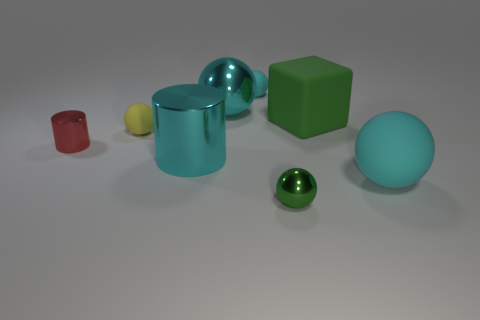Subtract all red cylinders. How many cyan balls are left? 3 Subtract 1 spheres. How many spheres are left? 4 Subtract all yellow spheres. How many spheres are left? 4 Subtract all small cyan matte spheres. How many spheres are left? 4 Subtract all purple balls. Subtract all green cylinders. How many balls are left? 5 Add 2 cubes. How many objects exist? 10 Subtract all blocks. How many objects are left? 7 Add 3 large gray shiny blocks. How many large gray shiny blocks exist? 3 Subtract 1 green balls. How many objects are left? 7 Subtract all yellow rubber things. Subtract all tiny red metallic things. How many objects are left? 6 